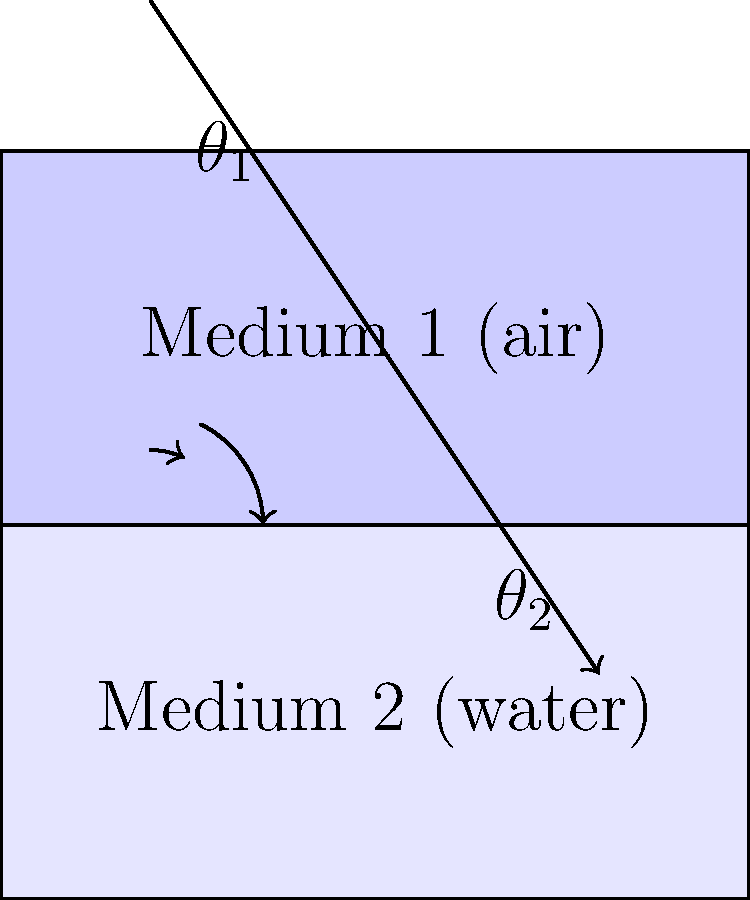In the context of political messaging, consider how different demographics receive and interpret information, analogous to light passing through different media. If a political message (represented by the light ray) passes from Medium 1 (air, representing the general public) to Medium 2 (water, representing a specific demographic), how does this relate to Snell's law of refraction? Assume the refractive index of air is 1.00 and that of water is 1.33. To understand this analogy, let's break down the concept step-by-step:

1) Snell's law of refraction is given by:
   $$n_1 \sin(\theta_1) = n_2 \sin(\theta_2)$$
   where $n_1$ and $n_2$ are the refractive indices of the two media, and $\theta_1$ and $\theta_2$ are the angles of incidence and refraction, respectively.

2) In our political analogy:
   - Medium 1 (air) represents the general public
   - Medium 2 (water) represents a specific demographic
   - The light ray represents the political message

3) As the message passes from the general public to the specific demographic, it changes direction (refracts), just as light does when passing from air to water.

4) The refractive index of the media represents how receptive or resistant a group is to the message. Higher refractive index means the message travels more slowly and bends more.

5) In this case, $n_1 = 1.00$ (air) and $n_2 = 1.33$ (water). Since $n_2 > n_1$, the message will bend towards the normal when entering the specific demographic, meaning it may be interpreted differently or have a different impact.

6) The angle of refraction $\theta_2$ will be smaller than the angle of incidence $\theta_1$, indicating that the message may become more focused or concentrated within the specific demographic.

7) This refraction effect explains why the same political message can have different impacts on various demographics, just as light bends differently in different media.

8) Politicians and strategists can use this understanding to tailor their messages for specific demographics, considering how the "refractive index" of each group might affect the reception and interpretation of their message.
Answer: Political messages refract (change direction) when moving between demographics, with the degree of change dependent on each group's receptivity (refractive index). 